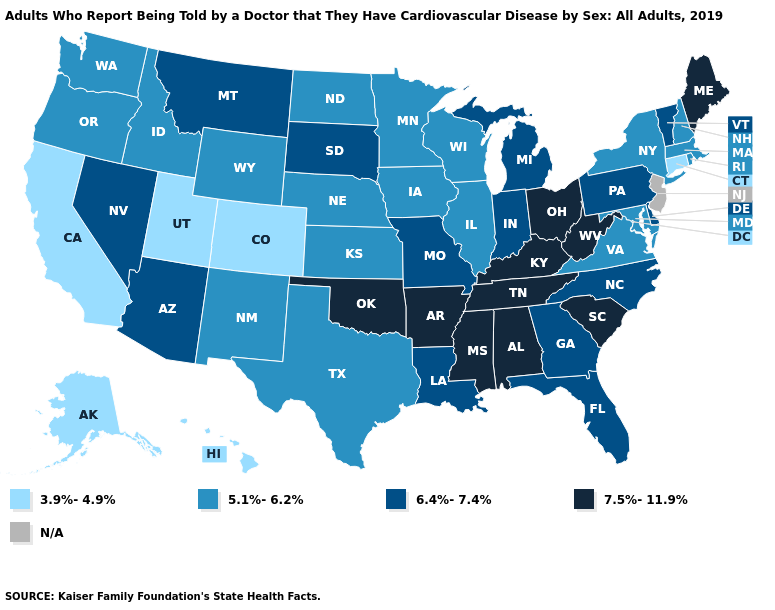Name the states that have a value in the range 6.4%-7.4%?
Be succinct. Arizona, Delaware, Florida, Georgia, Indiana, Louisiana, Michigan, Missouri, Montana, Nevada, North Carolina, Pennsylvania, South Dakota, Vermont. Does Virginia have the highest value in the USA?
Concise answer only. No. What is the value of Iowa?
Concise answer only. 5.1%-6.2%. Does the map have missing data?
Concise answer only. Yes. What is the value of Wisconsin?
Give a very brief answer. 5.1%-6.2%. Name the states that have a value in the range 5.1%-6.2%?
Write a very short answer. Idaho, Illinois, Iowa, Kansas, Maryland, Massachusetts, Minnesota, Nebraska, New Hampshire, New Mexico, New York, North Dakota, Oregon, Rhode Island, Texas, Virginia, Washington, Wisconsin, Wyoming. Which states have the lowest value in the Northeast?
Short answer required. Connecticut. What is the highest value in the West ?
Be succinct. 6.4%-7.4%. What is the value of Kansas?
Be succinct. 5.1%-6.2%. What is the highest value in states that border Colorado?
Keep it brief. 7.5%-11.9%. Among the states that border South Dakota , does Minnesota have the lowest value?
Give a very brief answer. Yes. What is the value of Colorado?
Concise answer only. 3.9%-4.9%. Is the legend a continuous bar?
Write a very short answer. No. Name the states that have a value in the range N/A?
Be succinct. New Jersey. 